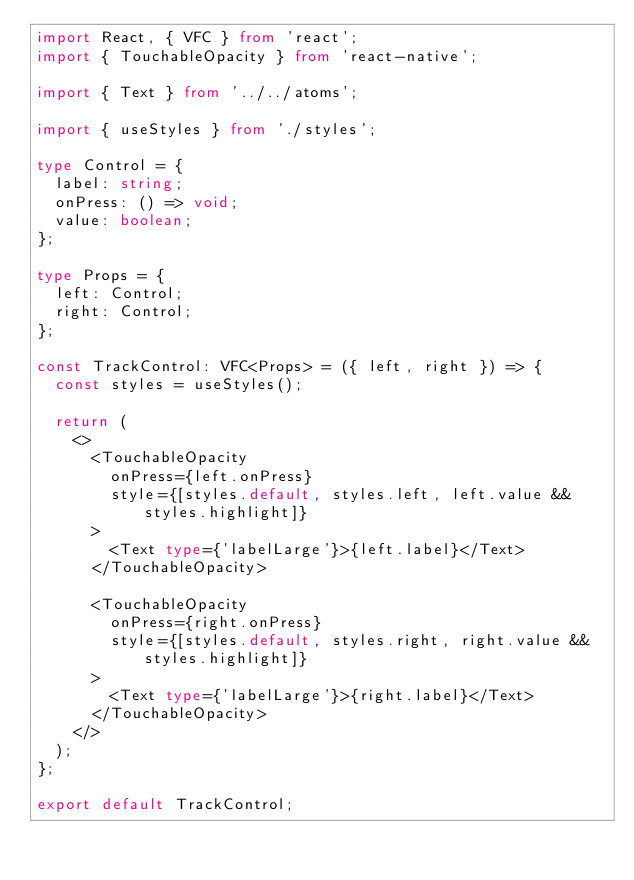Convert code to text. <code><loc_0><loc_0><loc_500><loc_500><_TypeScript_>import React, { VFC } from 'react';
import { TouchableOpacity } from 'react-native';

import { Text } from '../../atoms';

import { useStyles } from './styles';

type Control = {
  label: string;
  onPress: () => void;
  value: boolean;
};

type Props = {
  left: Control;
  right: Control;
};

const TrackControl: VFC<Props> = ({ left, right }) => {
  const styles = useStyles();

  return (
    <>
      <TouchableOpacity
        onPress={left.onPress}
        style={[styles.default, styles.left, left.value && styles.highlight]}
      >
        <Text type={'labelLarge'}>{left.label}</Text>
      </TouchableOpacity>

      <TouchableOpacity
        onPress={right.onPress}
        style={[styles.default, styles.right, right.value && styles.highlight]}
      >
        <Text type={'labelLarge'}>{right.label}</Text>
      </TouchableOpacity>
    </>
  );
};

export default TrackControl;
</code> 